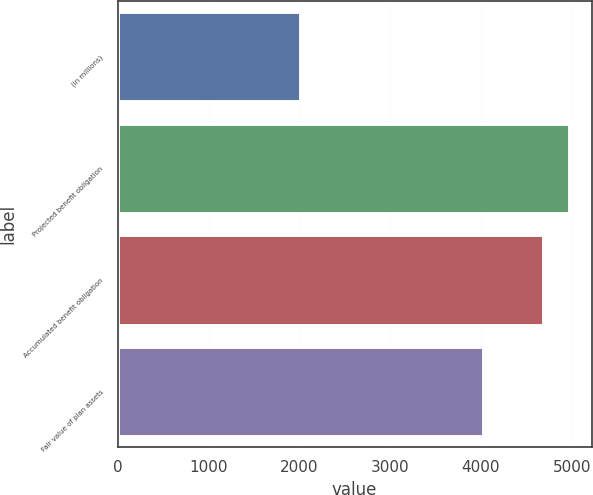<chart> <loc_0><loc_0><loc_500><loc_500><bar_chart><fcel>(in millions)<fcel>Projected benefit obligation<fcel>Accumulated benefit obligation<fcel>Fair value of plan assets<nl><fcel>2013<fcel>4969.9<fcel>4683<fcel>4024<nl></chart> 